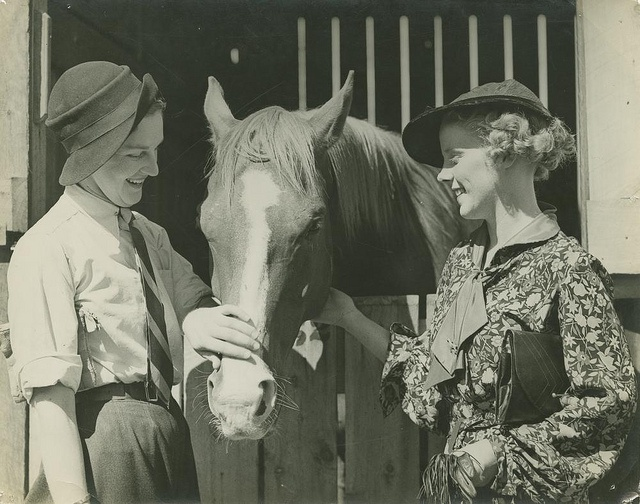Describe the objects in this image and their specific colors. I can see people in lightgray, gray, darkgray, black, and darkgreen tones, people in lightgray, gray, beige, and darkgray tones, horse in lightgray, darkgray, black, and gray tones, handbag in lightgray, black, darkgreen, and gray tones, and tie in lightgray, gray, black, and darkgray tones in this image. 